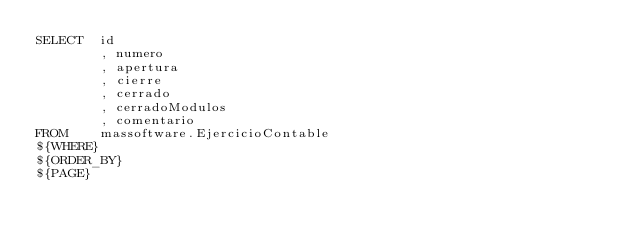Convert code to text. <code><loc_0><loc_0><loc_500><loc_500><_SQL_>SELECT	id
		, numero
		, apertura	
		, cierre
		, cerrado
		, cerradoModulos
		, comentario
FROM	massoftware.EjercicioContable
${WHERE}
${ORDER_BY}
${PAGE}</code> 